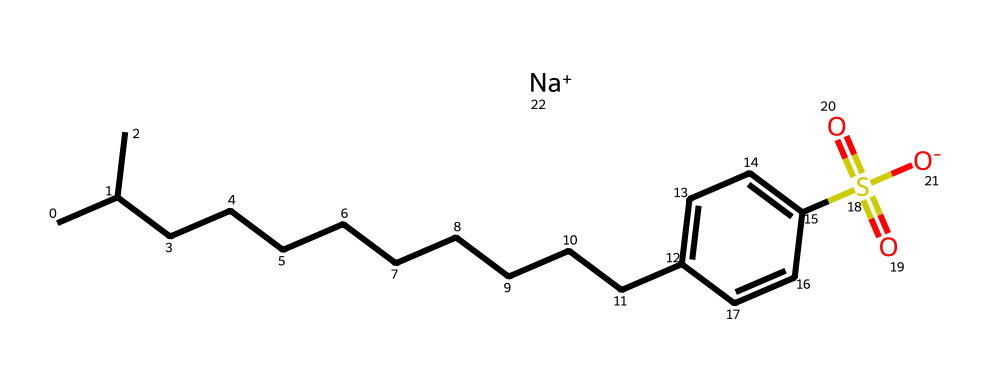What is the main functional group present in this chemical? The chemical contains a sulfonate group, which is identified by the presence of sulfur (S) bonded to oxygen (O) and carries a negative charge. This functional group is characteristic of alkylbenzene sulfonates.
Answer: sulfonate How many carbon atoms are in the longest continuous chain of this chemical? By examining the structure, the longest continuous carbon chain includes 12 carbon atoms in the aliphatic part (CCCCCCCCCCC).
Answer: 12 What is the total number of oxygen atoms in this chemical? The structure has two oxygen atoms from the sulfonate group and one from the sulfonic acid derivative, equaling three oxygen atoms in total.
Answer: 3 Is this compound likely to be biodegradable? Linear alkylbenzene sulfonates are generally known for their biodegradability, due to their structure which allows for microbial breakdown.
Answer: Yes What type of surfactant is this chemical classified as? This chemical is classified as an anionic surfactant because of the negatively charged sulfonate group, which is characteristic of detergents that can effectively lower surface tension.
Answer: anionic surfactant How does the presence of a benzene ring affect the solubility of this detergent? The benzene ring contributes to hydrophobic characteristics, making the molecule amphiphilic, crucial for solubility in both water and oils, enhancing its effectiveness as a detergent.
Answer: amphiphilic 